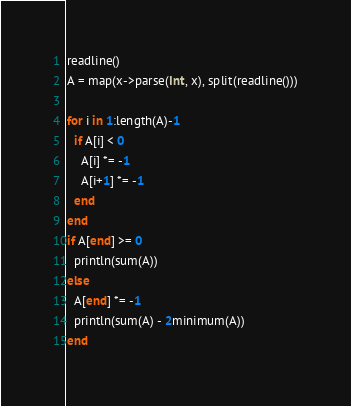<code> <loc_0><loc_0><loc_500><loc_500><_Julia_>readline()
A = map(x->parse(Int, x), split(readline()))

for i in 1:length(A)-1
  if A[i] < 0
    A[i] *= -1
    A[i+1] *= -1
  end
end
if A[end] >= 0
  println(sum(A))
else
  A[end] *= -1
  println(sum(A) - 2minimum(A))
end</code> 